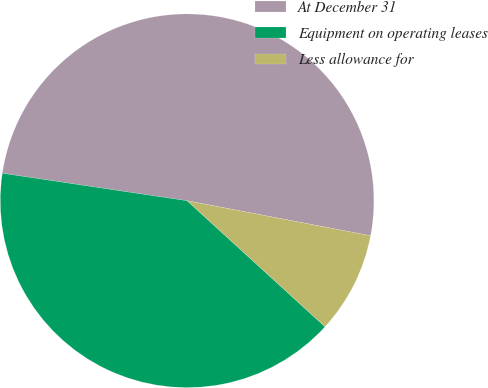Convert chart to OTSL. <chart><loc_0><loc_0><loc_500><loc_500><pie_chart><fcel>At December 31<fcel>Equipment on operating leases<fcel>Less allowance for<nl><fcel>50.65%<fcel>40.57%<fcel>8.78%<nl></chart> 